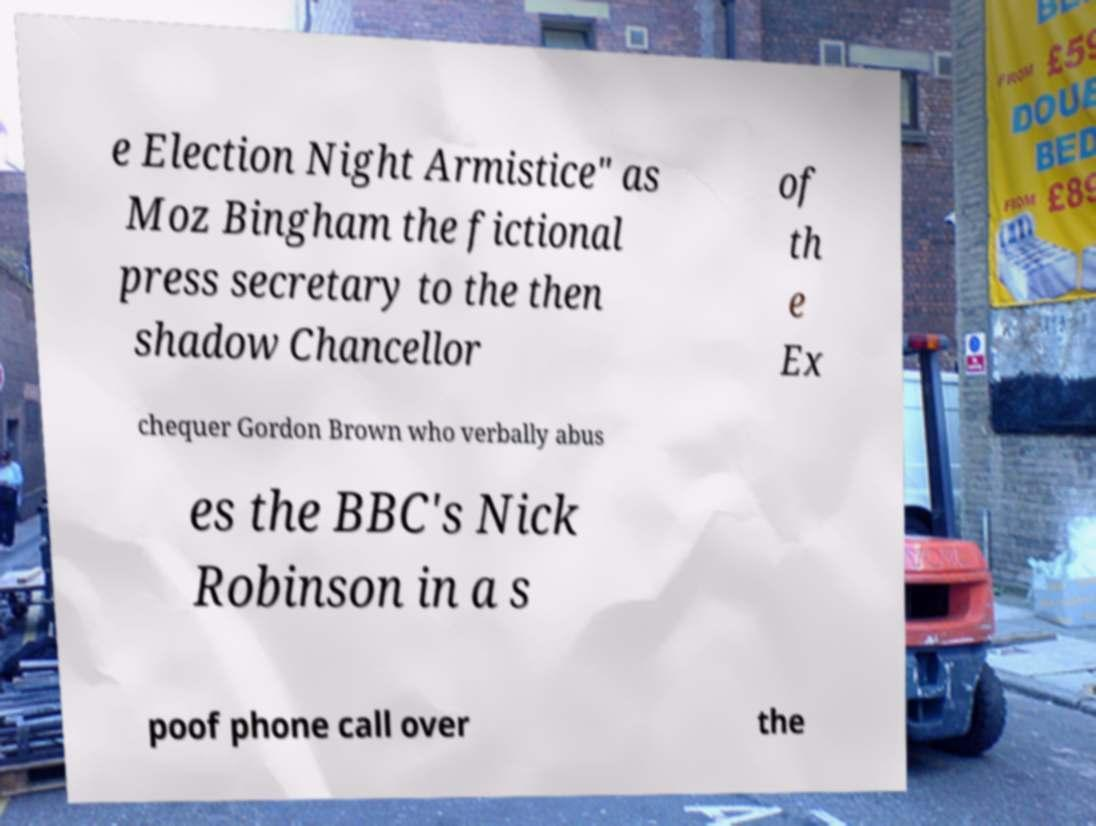Could you extract and type out the text from this image? e Election Night Armistice" as Moz Bingham the fictional press secretary to the then shadow Chancellor of th e Ex chequer Gordon Brown who verbally abus es the BBC's Nick Robinson in a s poof phone call over the 